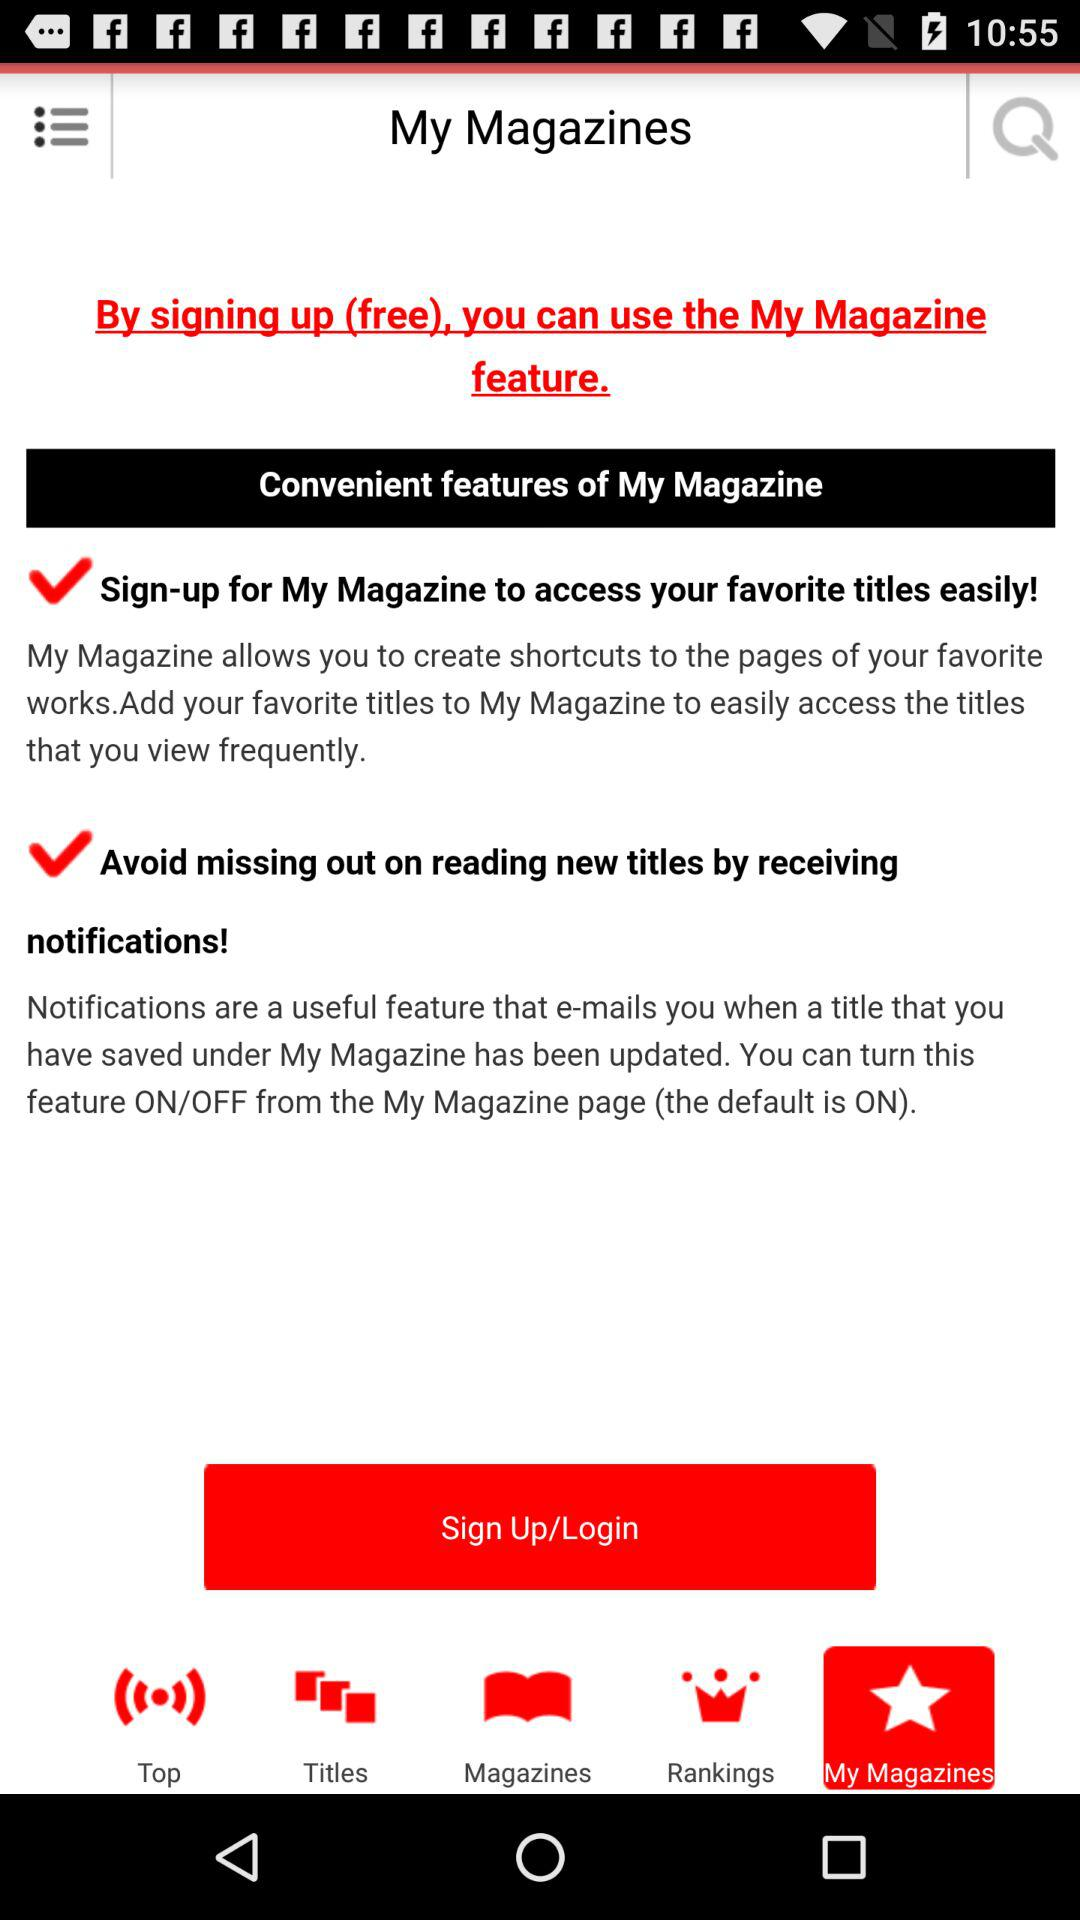How many check marks are there on the screen?
Answer the question using a single word or phrase. 2 